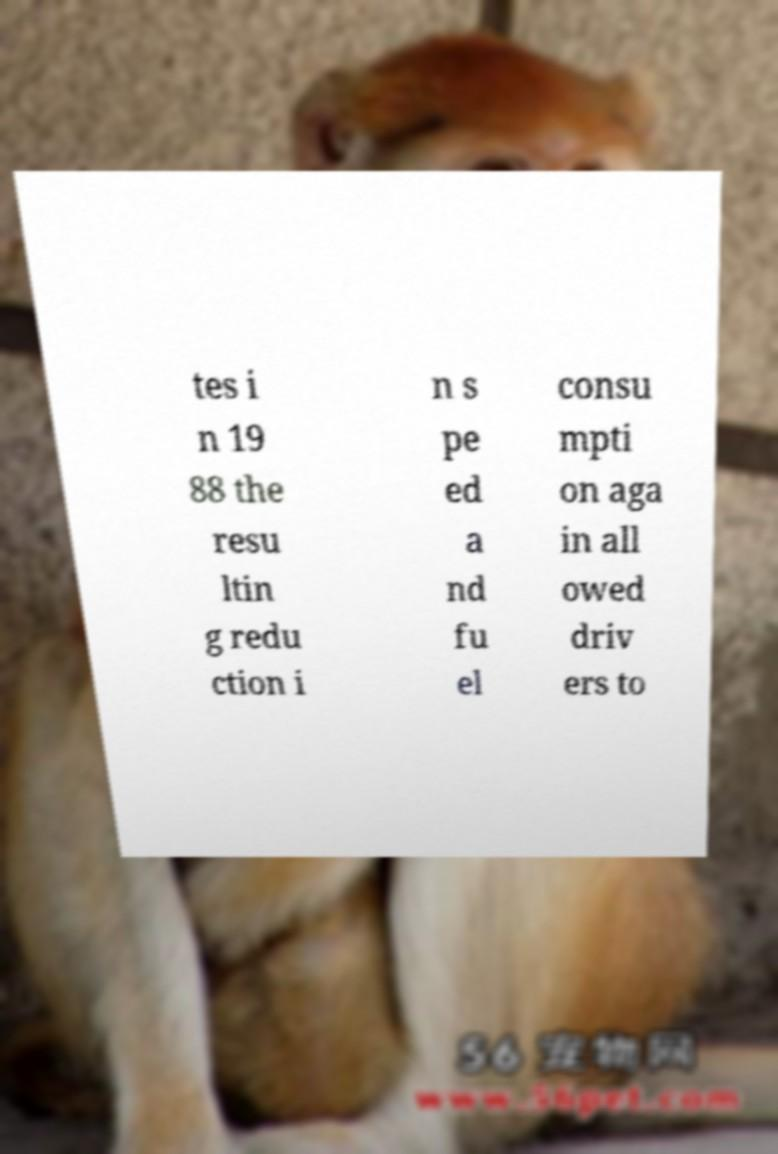Can you accurately transcribe the text from the provided image for me? tes i n 19 88 the resu ltin g redu ction i n s pe ed a nd fu el consu mpti on aga in all owed driv ers to 